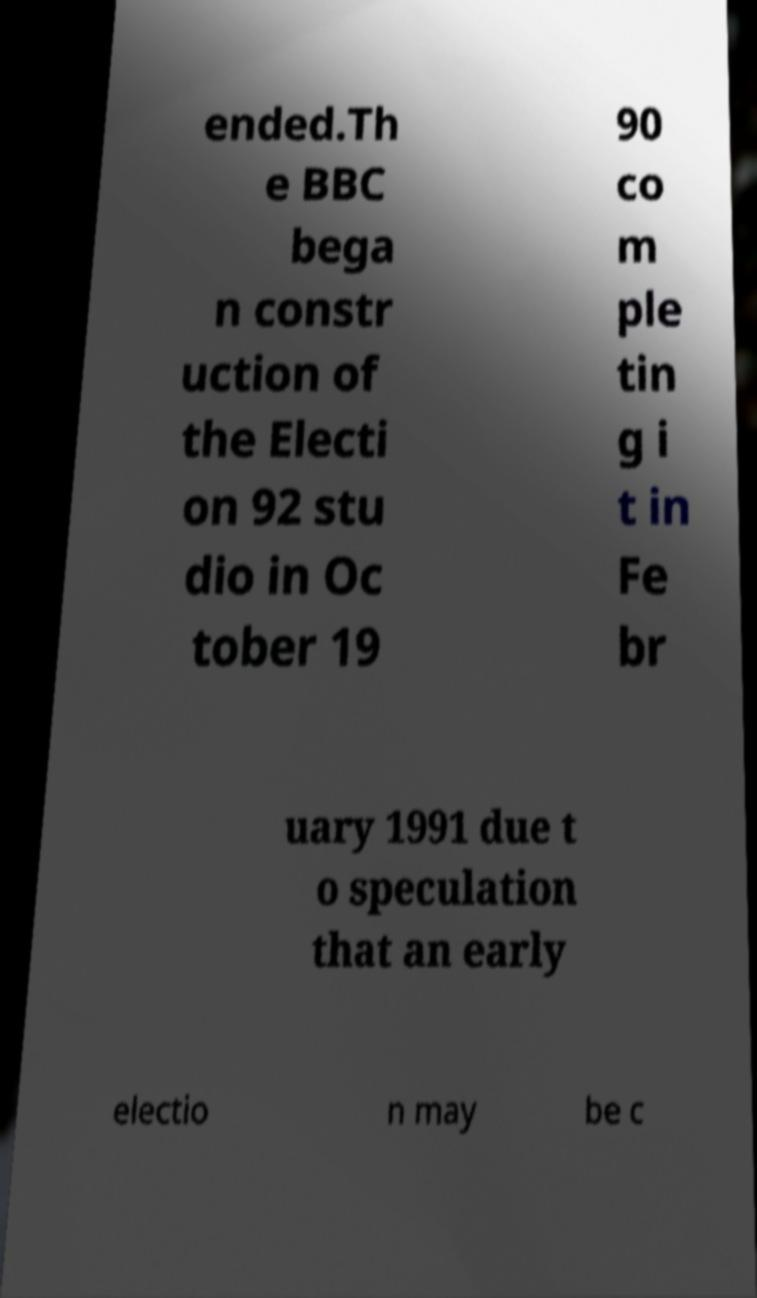There's text embedded in this image that I need extracted. Can you transcribe it verbatim? ended.Th e BBC bega n constr uction of the Electi on 92 stu dio in Oc tober 19 90 co m ple tin g i t in Fe br uary 1991 due t o speculation that an early electio n may be c 